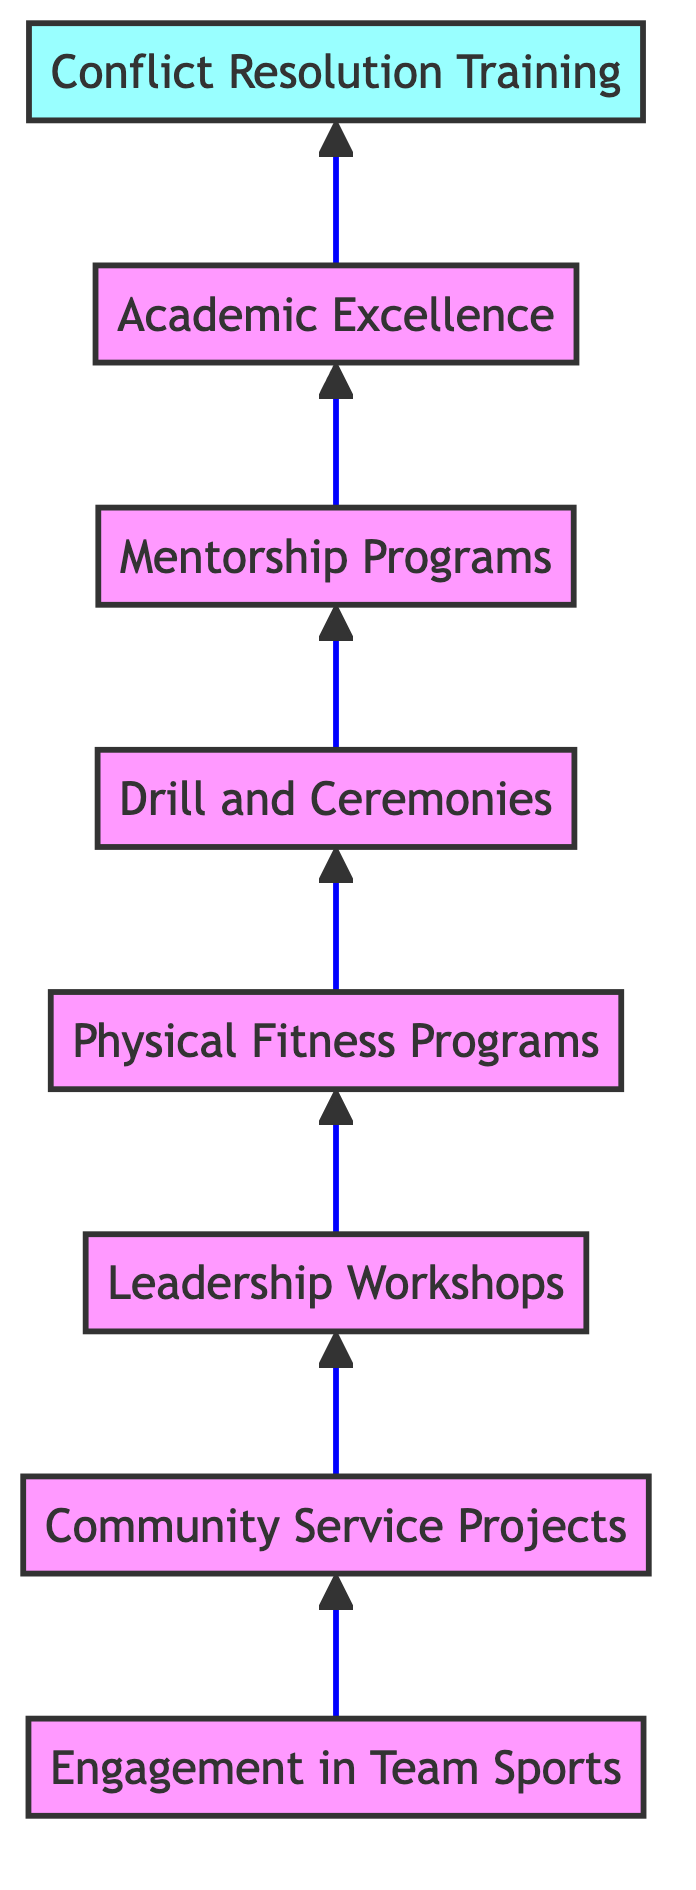What is the first element in the flow chart? The first element at the bottom of the flow chart is "Engagement in Team Sports." This is determined by looking at the flow direction, which starts from the bottom and flows upward, identifying the first item listed.
Answer: Engagement in Team Sports How many elements are present in the diagram? The diagram lists a total of eight elements, each representing a different activity contributing to character development. This can be counted directly from the elements listed in the diagram.
Answer: 8 What activity is the last node before "Conflict Resolution Training"? The last node before "Conflict Resolution Training" is "Academic Excellence." This is found by identifying the node directly connected to "Conflict Resolution Training."
Answer: Academic Excellence What role does "Drill and Ceremonies" play within the flow of the chart? "Drill and Ceremonies" is the fifth node in the flow, positioned between "Physical Fitness Programs" and "Mentorship Programs." It indicates that participation in drill practice contributes to the development of character traits after physical fitness.
Answer: Fifth How does "Engagement in Team Sports" relate to "Community Service Projects"? "Engagement in Team Sports" leads directly to "Community Service Projects." This means that participation in team sports may facilitate and promote involvement in community service, as indicated by the upward flow of the chart.
Answer: Leads to What is the connection between "Mentorship Programs" and "Leadership Workshops"? "Mentorship Programs" follows "Drill and Ceremonies" and is preceded by "Leadership Workshops," creating a flow where leadership development from workshops may be reinforced through mentoring practices. This indicates a sequential relationship in the development of character traits.
Answer: Sequential relationship How many activities are focused on leadership development in the flow chart? There are three activities directly focused on leadership development: "Leadership Workshops," "Mentorship Programs," and the implicit leadership skills that come from the earlier activities such as "Drill and Ceremonies." Counting these gives a total of three.
Answer: 3 What two activities directly precede "Academic Excellence"? The two activities that directly precede "Academic Excellence" are "Mentorship Programs" and "Drill and Ceremonies." This indicates that both the mentorship and drill practices contribute to achieving academic success.
Answer: Mentorship Programs and Drill and Ceremonies What is the overall goal represented at the top of the flow chart? The overall goal represented at the top of the flow chart is "Conflict Resolution Training," implying that this is a culmination of various character development processes depicted in the chart.
Answer: Conflict Resolution Training 